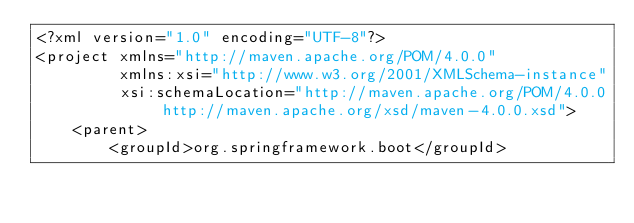<code> <loc_0><loc_0><loc_500><loc_500><_XML_><?xml version="1.0" encoding="UTF-8"?>
<project xmlns="http://maven.apache.org/POM/4.0.0"
         xmlns:xsi="http://www.w3.org/2001/XMLSchema-instance"
         xsi:schemaLocation="http://maven.apache.org/POM/4.0.0 http://maven.apache.org/xsd/maven-4.0.0.xsd">
    <parent>
        <groupId>org.springframework.boot</groupId></code> 